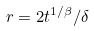Convert formula to latex. <formula><loc_0><loc_0><loc_500><loc_500>r = 2 t ^ { 1 / \beta } / \delta</formula> 